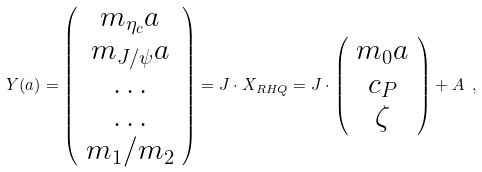<formula> <loc_0><loc_0><loc_500><loc_500>Y ( a ) = \left ( \begin{array} { c } m _ { \eta _ { c } } a \\ m _ { J / \psi } a \\ \dots \\ \dots \\ m _ { 1 } / m _ { 2 } \end{array} \right ) = J \cdot X _ { R H Q } = J \cdot \left ( \begin{array} { c } m _ { 0 } a \\ c _ { P } \\ \zeta \end{array} \right ) + A \ ,</formula> 